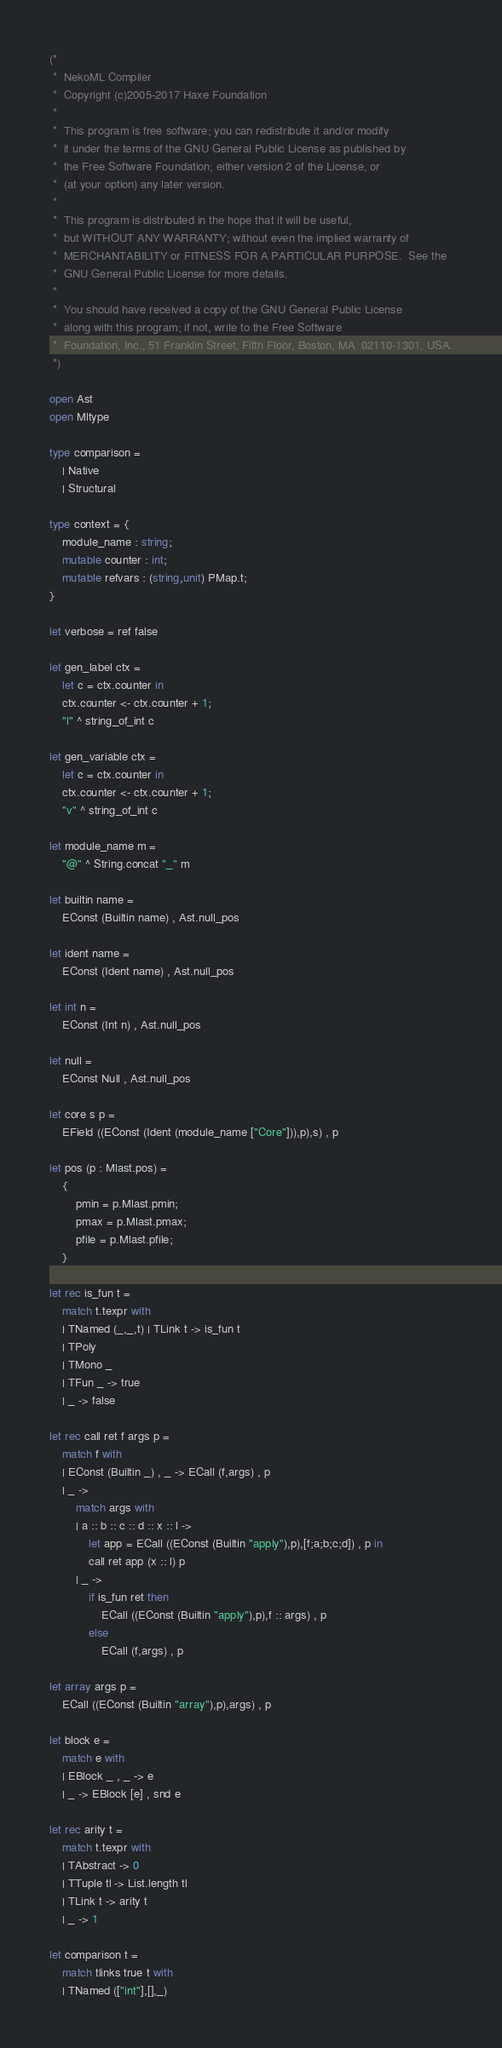<code> <loc_0><loc_0><loc_500><loc_500><_OCaml_>(*
 *  NekoML Compiler
 *  Copyright (c)2005-2017 Haxe Foundation
 *
 *  This program is free software; you can redistribute it and/or modify
 *  it under the terms of the GNU General Public License as published by
 *  the Free Software Foundation; either version 2 of the License, or
 *  (at your option) any later version.
 *
 *  This program is distributed in the hope that it will be useful,
 *  but WITHOUT ANY WARRANTY; without even the implied warranty of
 *  MERCHANTABILITY or FITNESS FOR A PARTICULAR PURPOSE.  See the
 *  GNU General Public License for more details.
 *
 *  You should have received a copy of the GNU General Public License
 *  along with this program; if not, write to the Free Software
 *  Foundation, Inc., 51 Franklin Street, Fifth Floor, Boston, MA  02110-1301, USA.
 *)
 
open Ast
open Mltype

type comparison =
	| Native
	| Structural	

type context = {
	module_name : string;
	mutable counter : int;
	mutable refvars : (string,unit) PMap.t;
}

let verbose = ref false

let gen_label ctx =
	let c = ctx.counter in
	ctx.counter <- ctx.counter + 1;
	"l" ^ string_of_int c

let gen_variable ctx =
	let c = ctx.counter in
	ctx.counter <- ctx.counter + 1;
	"v" ^ string_of_int c

let module_name m =
	"@" ^ String.concat "_" m

let builtin name =
	EConst (Builtin name) , Ast.null_pos

let ident name =
	EConst (Ident name) , Ast.null_pos

let int n =
	EConst (Int n) , Ast.null_pos

let null =
	EConst Null , Ast.null_pos

let core s p =
	EField ((EConst (Ident (module_name ["Core"])),p),s) , p

let pos (p : Mlast.pos) = 
	{
		pmin = p.Mlast.pmin;
		pmax = p.Mlast.pmax;
		pfile = p.Mlast.pfile;
	}

let rec is_fun t =
	match t.texpr with
	| TNamed (_,_,t) | TLink t -> is_fun t
	| TPoly
	| TMono _
	| TFun _ -> true
	| _ -> false

let rec call ret f args p =
	match f with
	| EConst (Builtin _) , _ -> ECall (f,args) , p
	| _ ->
		match args with
		| a :: b :: c :: d :: x :: l -> 
			let app = ECall ((EConst (Builtin "apply"),p),[f;a;b;c;d]) , p in
			call ret app (x :: l) p
		| _ ->
			if is_fun ret then
				ECall ((EConst (Builtin "apply"),p),f :: args) , p
			else
				ECall (f,args) , p

let array args p =
	ECall ((EConst (Builtin "array"),p),args) , p

let block e =
	match e with
	| EBlock _ , _ -> e 
	| _ -> EBlock [e] , snd e

let rec arity t =
	match t.texpr with
	| TAbstract -> 0
	| TTuple tl -> List.length tl
	| TLink t -> arity t
	| _ -> 1

let comparison t =
	match tlinks true t with
	| TNamed (["int"],[],_)</code> 